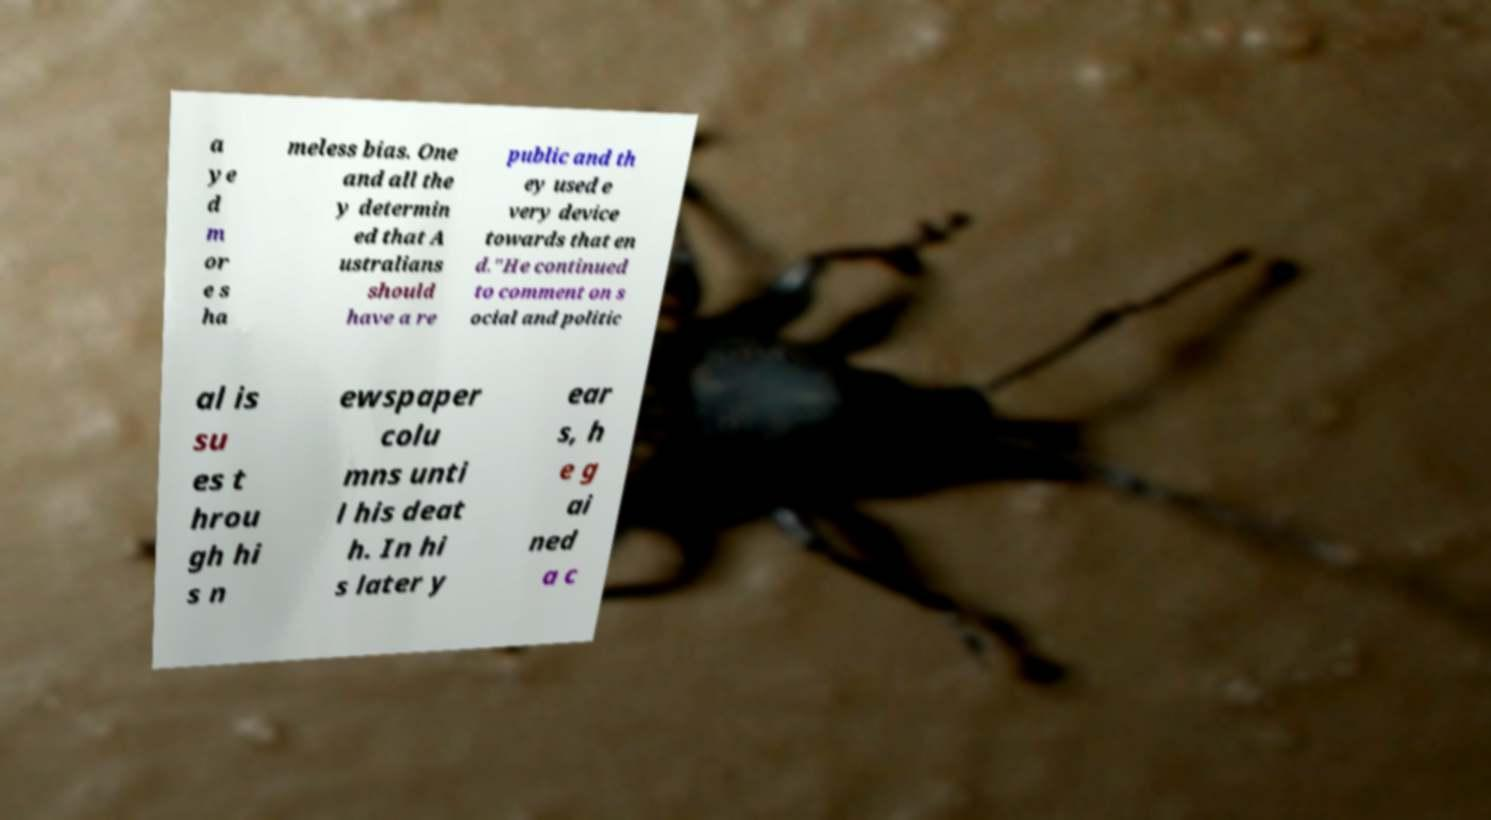Can you read and provide the text displayed in the image?This photo seems to have some interesting text. Can you extract and type it out for me? a ye d m or e s ha meless bias. One and all the y determin ed that A ustralians should have a re public and th ey used e very device towards that en d."He continued to comment on s ocial and politic al is su es t hrou gh hi s n ewspaper colu mns unti l his deat h. In hi s later y ear s, h e g ai ned a c 